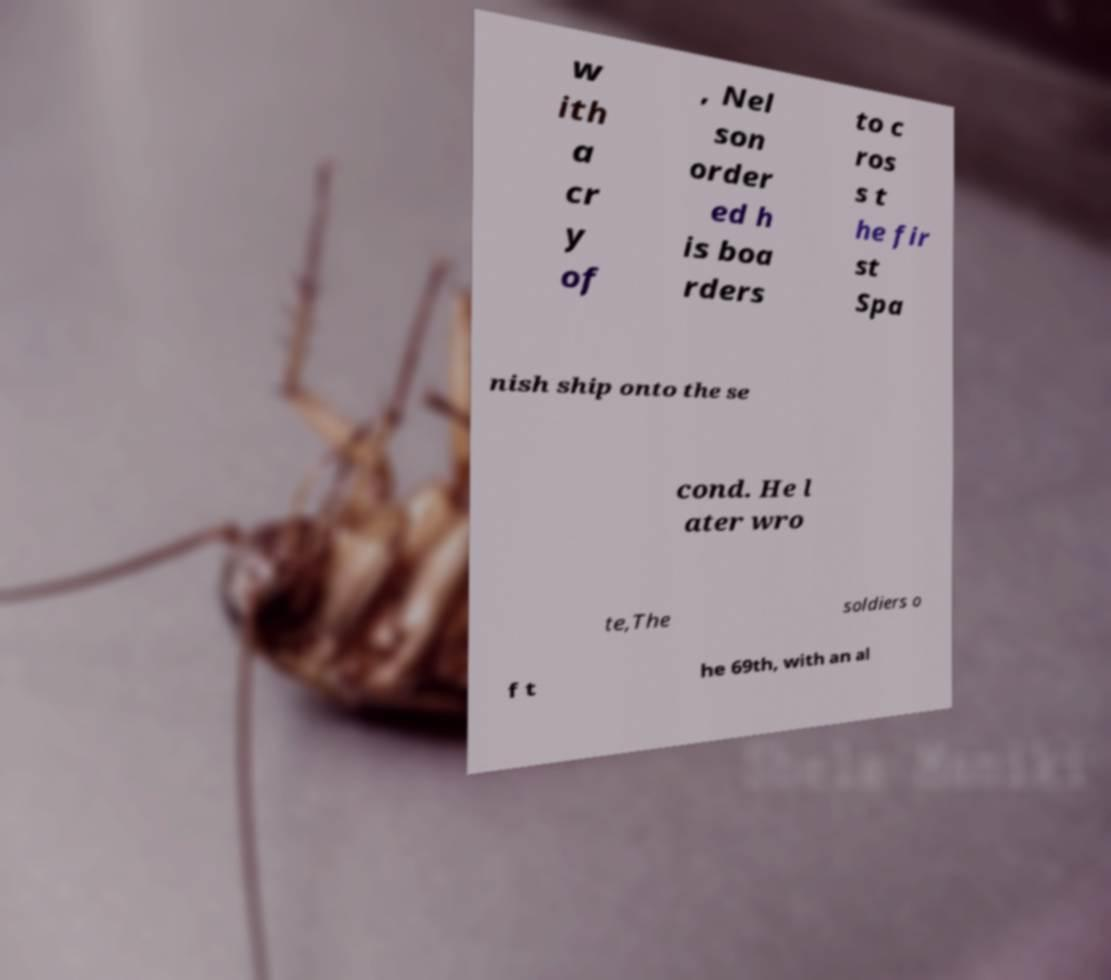Could you extract and type out the text from this image? w ith a cr y of , Nel son order ed h is boa rders to c ros s t he fir st Spa nish ship onto the se cond. He l ater wro te,The soldiers o f t he 69th, with an al 